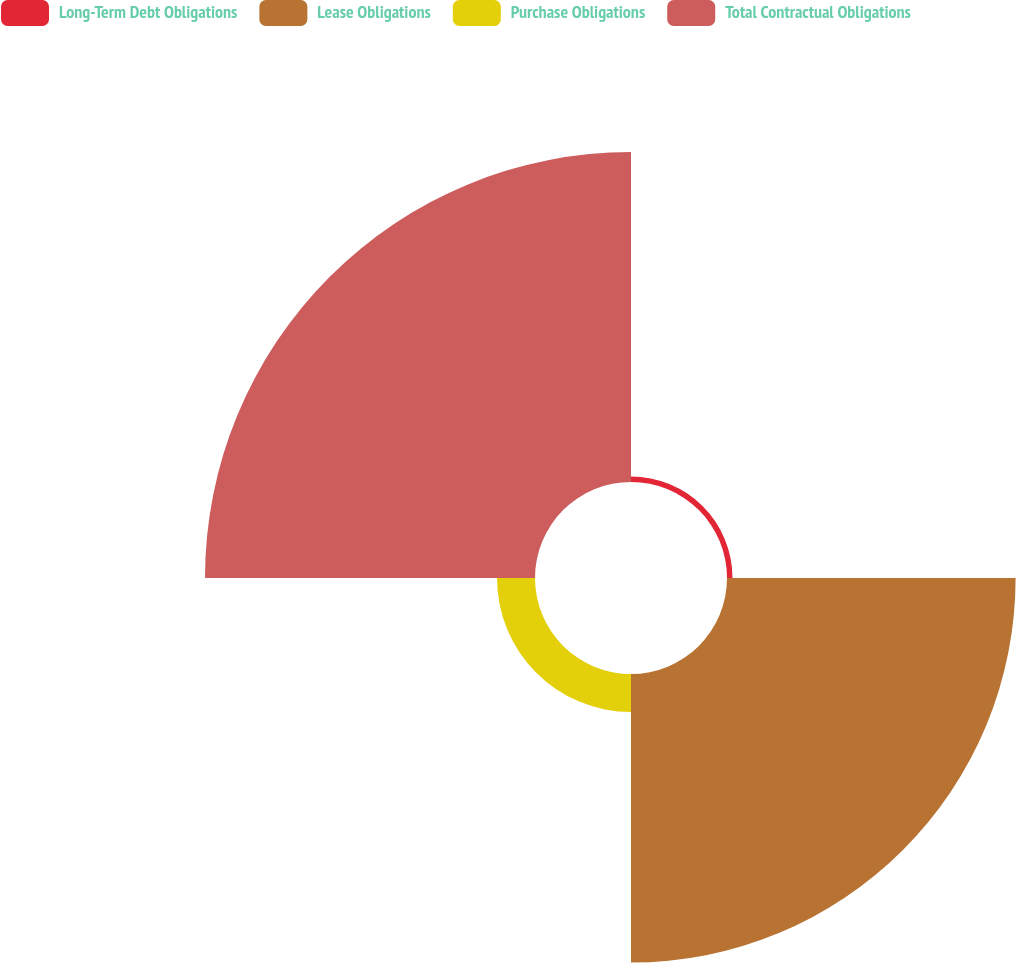Convert chart to OTSL. <chart><loc_0><loc_0><loc_500><loc_500><pie_chart><fcel>Long-Term Debt Obligations<fcel>Lease Obligations<fcel>Purchase Obligations<fcel>Total Contractual Obligations<nl><fcel>0.83%<fcel>43.59%<fcel>5.74%<fcel>49.84%<nl></chart> 